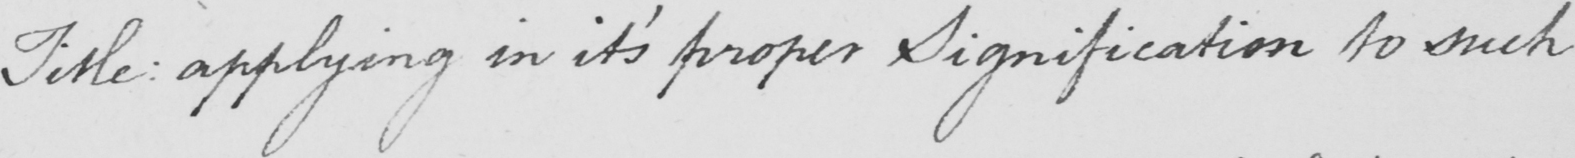What does this handwritten line say? Title :  applying in it ' s proper Signification to such 